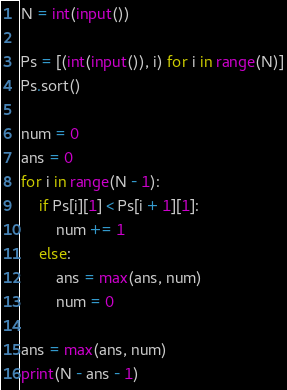<code> <loc_0><loc_0><loc_500><loc_500><_Python_>N = int(input())

Ps = [(int(input()), i) for i in range(N)]
Ps.sort()

num = 0
ans = 0
for i in range(N - 1):
    if Ps[i][1] < Ps[i + 1][1]:
        num += 1
    else:
        ans = max(ans, num)
        num = 0
    
ans = max(ans, num)
print(N - ans - 1)
</code> 